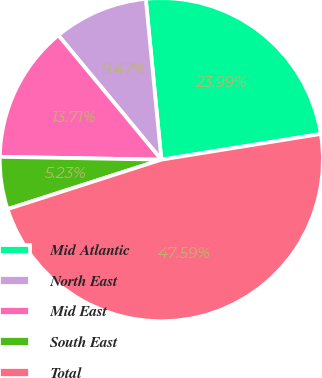Convert chart to OTSL. <chart><loc_0><loc_0><loc_500><loc_500><pie_chart><fcel>Mid Atlantic<fcel>North East<fcel>Mid East<fcel>South East<fcel>Total<nl><fcel>23.99%<fcel>9.47%<fcel>13.71%<fcel>5.23%<fcel>47.59%<nl></chart> 